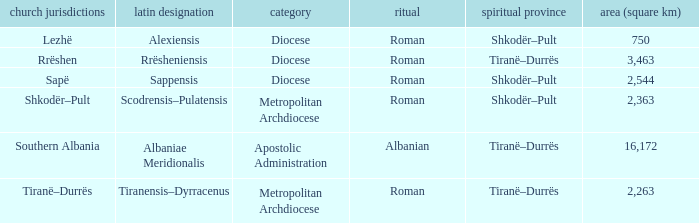What is the classification for rite albanian? Apostolic Administration. 